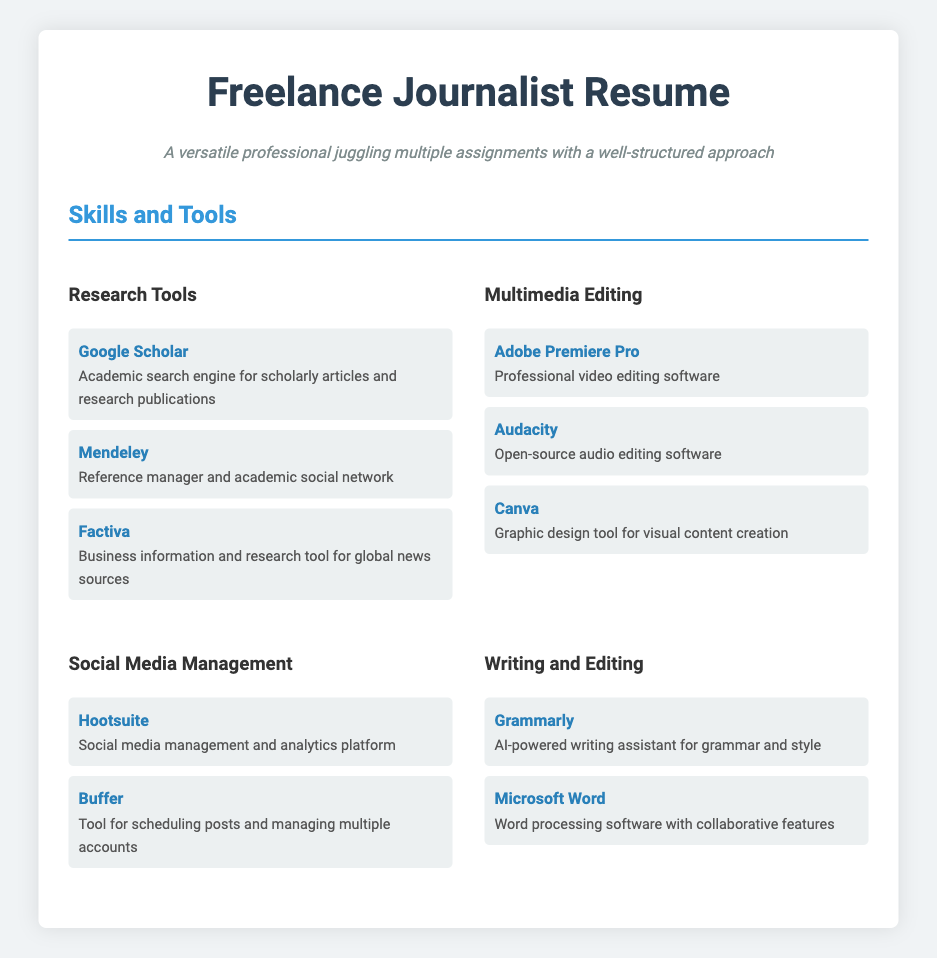What are the three categories of skills listed? The skills are organized into categories such as Research Tools, Multimedia Editing, Social Media Management, and Writing and Editing.
Answer: Research Tools, Multimedia Editing, Social Media Management, Writing and Editing How many tools are mentioned under Social Media Management? There are two tools listed under Social Media Management: Hootsuite and Buffer.
Answer: 2 Which multimedia editing software is used for audio editing? The document lists Audacity as the open-source audio editing software.
Answer: Audacity What type of tool is Mendeley classified as? Mendeley is classified as a reference manager and academic social network.
Answer: Reference manager What writing assistant is mentioned in the document? Grammarly is mentioned as the AI-powered writing assistant for grammar and style.
Answer: Grammarly Which software is used for professional video editing? Adobe Premiere Pro is identified as the professional video editing software.
Answer: Adobe Premiere Pro What color is used for the headings in the skills section? The color for the headings in the skills section is #3498db.
Answer: #3498db How many multimedia editing tools are listed? The document mentions three multimedia editing tools.
Answer: 3 